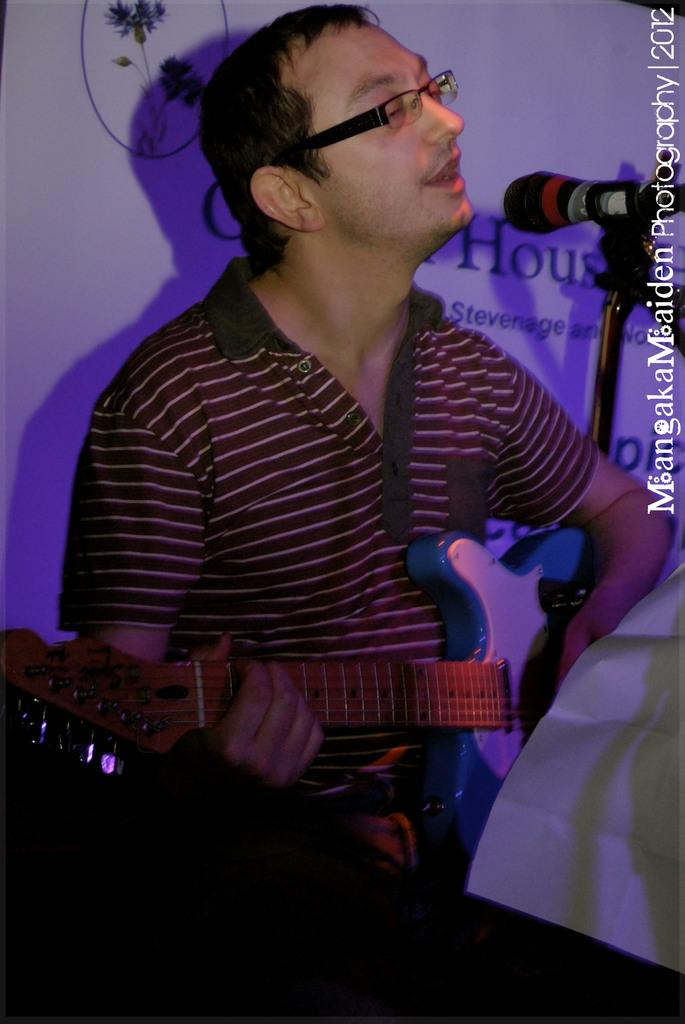What is the person in the image doing? The person is sitting and singing. What object is the person holding in the image? The person is holding a guitar. What is in front of the person that might be used for amplifying their voice? There is a microphone in front of the person. What can be seen at the back of the person? There is a banner at the back of the person. What type of drawer can be seen in the image? There is no drawer present in the image. Is the person on a board or a ship in the image? The image does not show the person on a board or a ship; they are sitting in a location with a banner and a microphone. 